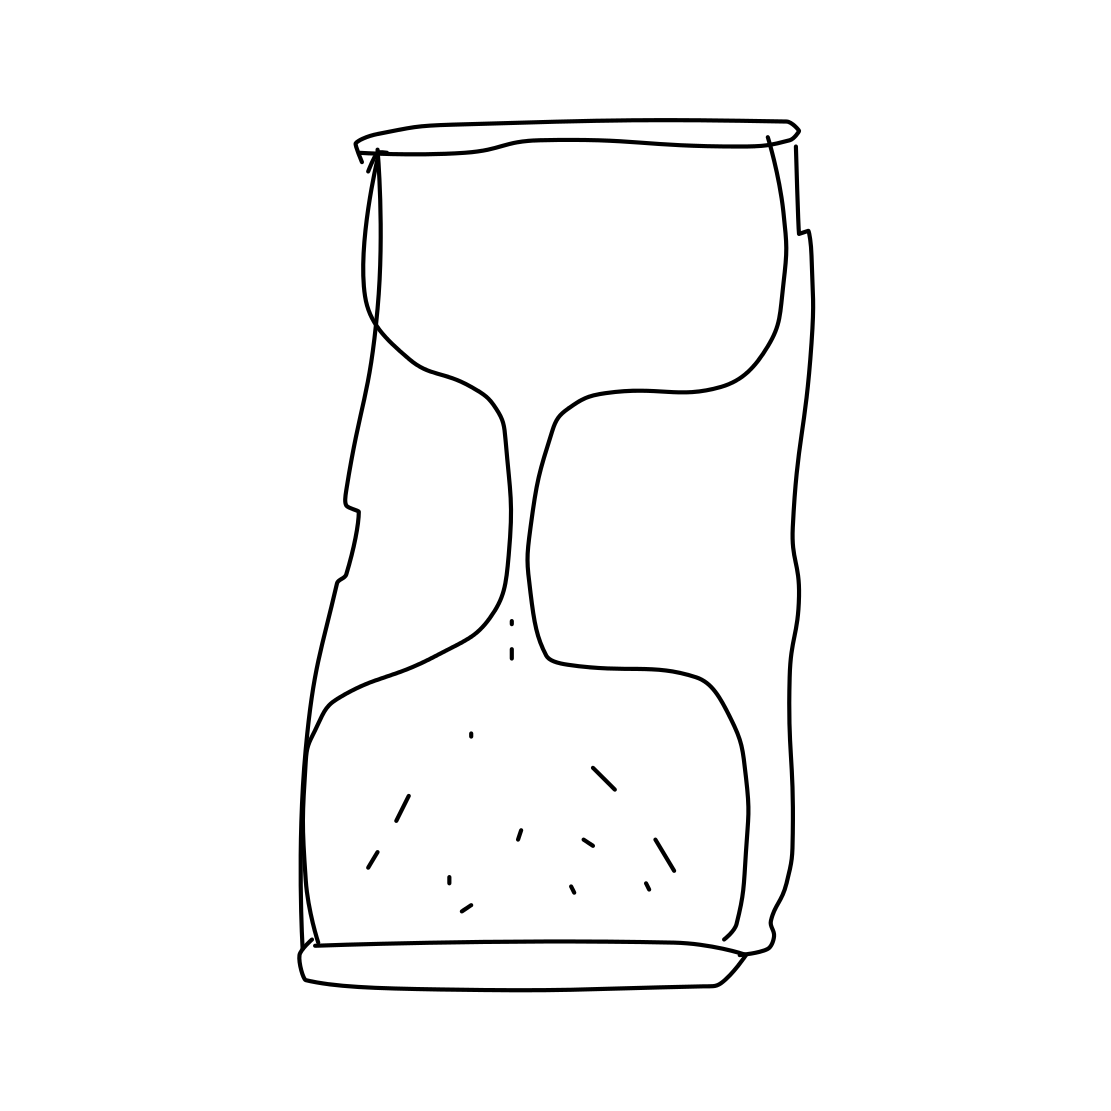What do you think this image represents? The image appears to represent an abstract form, possibly a stylized or distorted representation of a cylindrical object. The irregular contours suggest a creative interpretation rather than a realistic depiction of a physical object. Could it have a specific meaning or symbolism? Art is open to interpretation, and such an abstract design might evoke different feelings or ideas. It could symbolize transformation, fluidity, or even the imperfection inherent in life. The sparse details and minimalistic lines leave much to the viewer's imagination. 